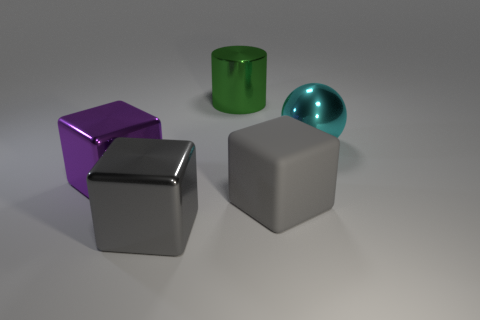Subtract all gray blocks. How many blocks are left? 1 Subtract all cyan spheres. How many gray cubes are left? 2 Subtract all cubes. How many objects are left? 2 Add 2 metallic cylinders. How many objects exist? 7 Subtract all purple cubes. How many cubes are left? 2 Subtract 2 blocks. How many blocks are left? 1 Subtract all brown cylinders. Subtract all green spheres. How many cylinders are left? 1 Subtract all green cylinders. Subtract all big gray things. How many objects are left? 2 Add 1 big green metal things. How many big green metal things are left? 2 Add 4 large gray rubber objects. How many large gray rubber objects exist? 5 